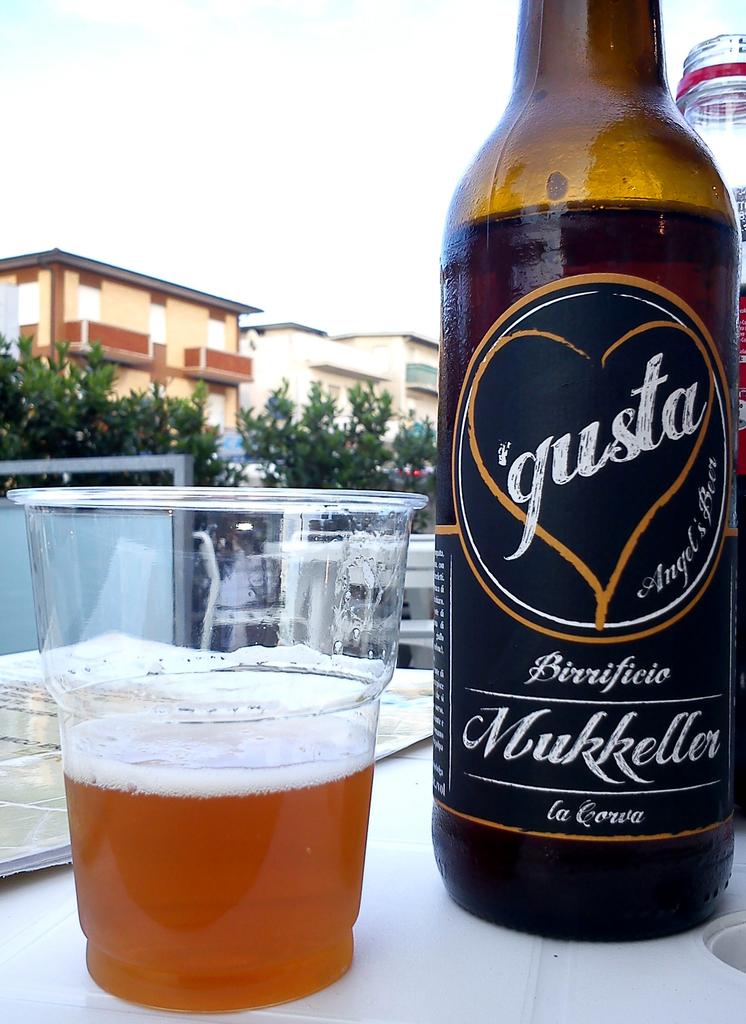What brand of alcohol is this beer?
Provide a short and direct response. Gusta. What does the right beer label say?
Your answer should be compact. Gusta. 